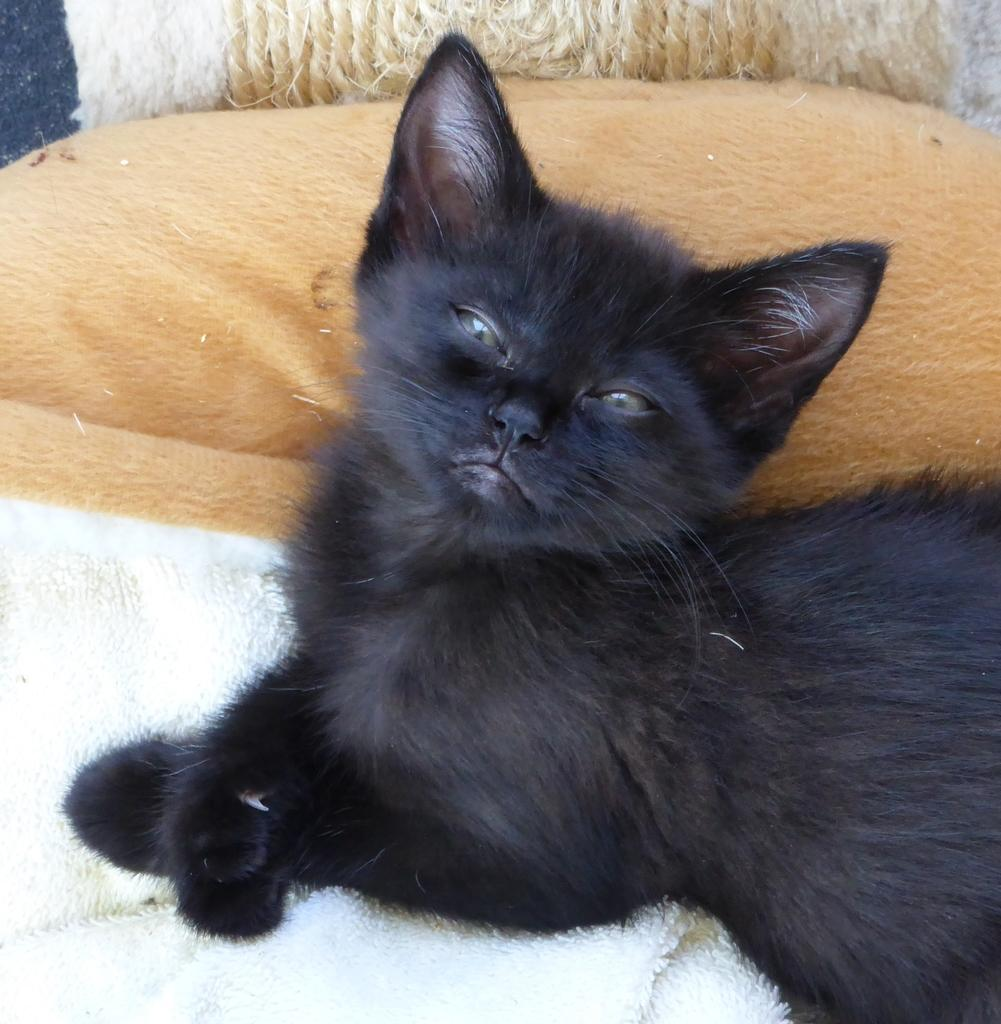What type of animal is in the image? There is a black color cat in the image. What is the cat sitting on? The cat is sitting on a white color cloth. Can you describe any other objects in the image? There is a pillow in the image. Where is the lunchroom located in the image? There is no lunchroom present in the image; it features a black color cat sitting on a white color cloth with a pillow nearby. 